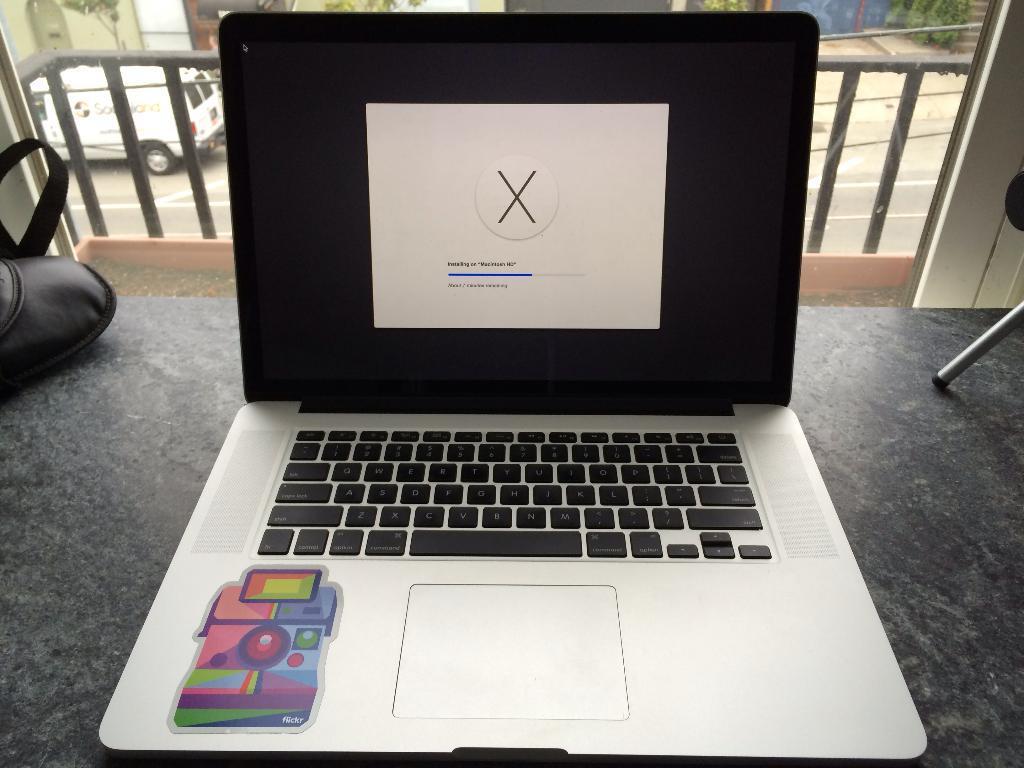Describe this image in one or two sentences. There is one laptop present on the floor as we can see at the bottom of this image. We can see a fence and a vehicle in the background. 